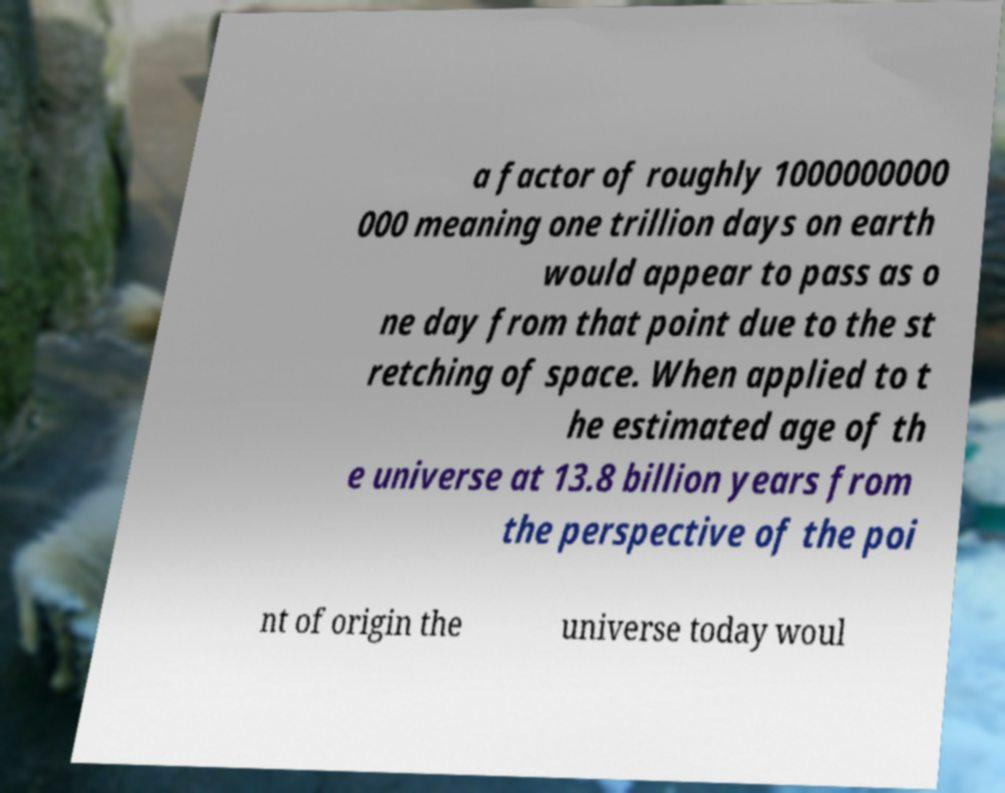For documentation purposes, I need the text within this image transcribed. Could you provide that? a factor of roughly 1000000000 000 meaning one trillion days on earth would appear to pass as o ne day from that point due to the st retching of space. When applied to t he estimated age of th e universe at 13.8 billion years from the perspective of the poi nt of origin the universe today woul 